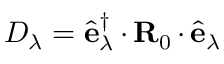<formula> <loc_0><loc_0><loc_500><loc_500>D _ { \lambda } = \hat { e } _ { \lambda } ^ { \dagger } \, { \cdot } \, { R } _ { 0 } \, { \cdot } \, \hat { e } _ { \lambda }</formula> 